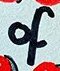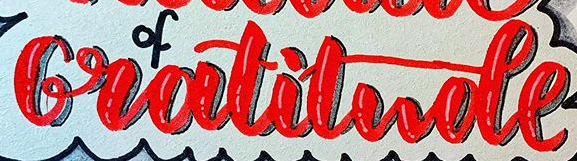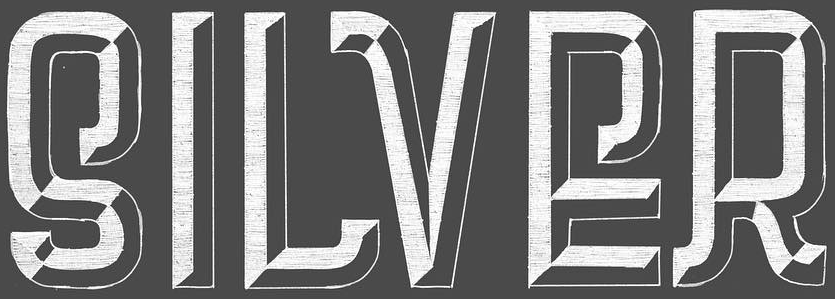Identify the words shown in these images in order, separated by a semicolon. of; Gratitude; SILVER 